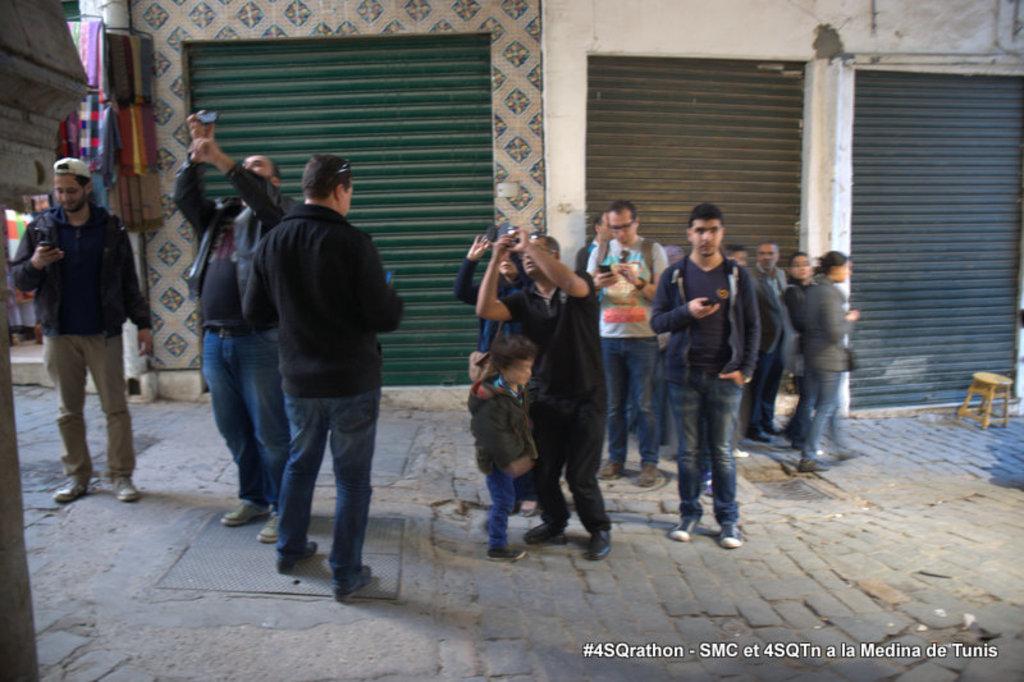Can you describe this image briefly? In this image I can see few people standing and few people holding something. Back I can few shutters,few objects,stool and the wall. 